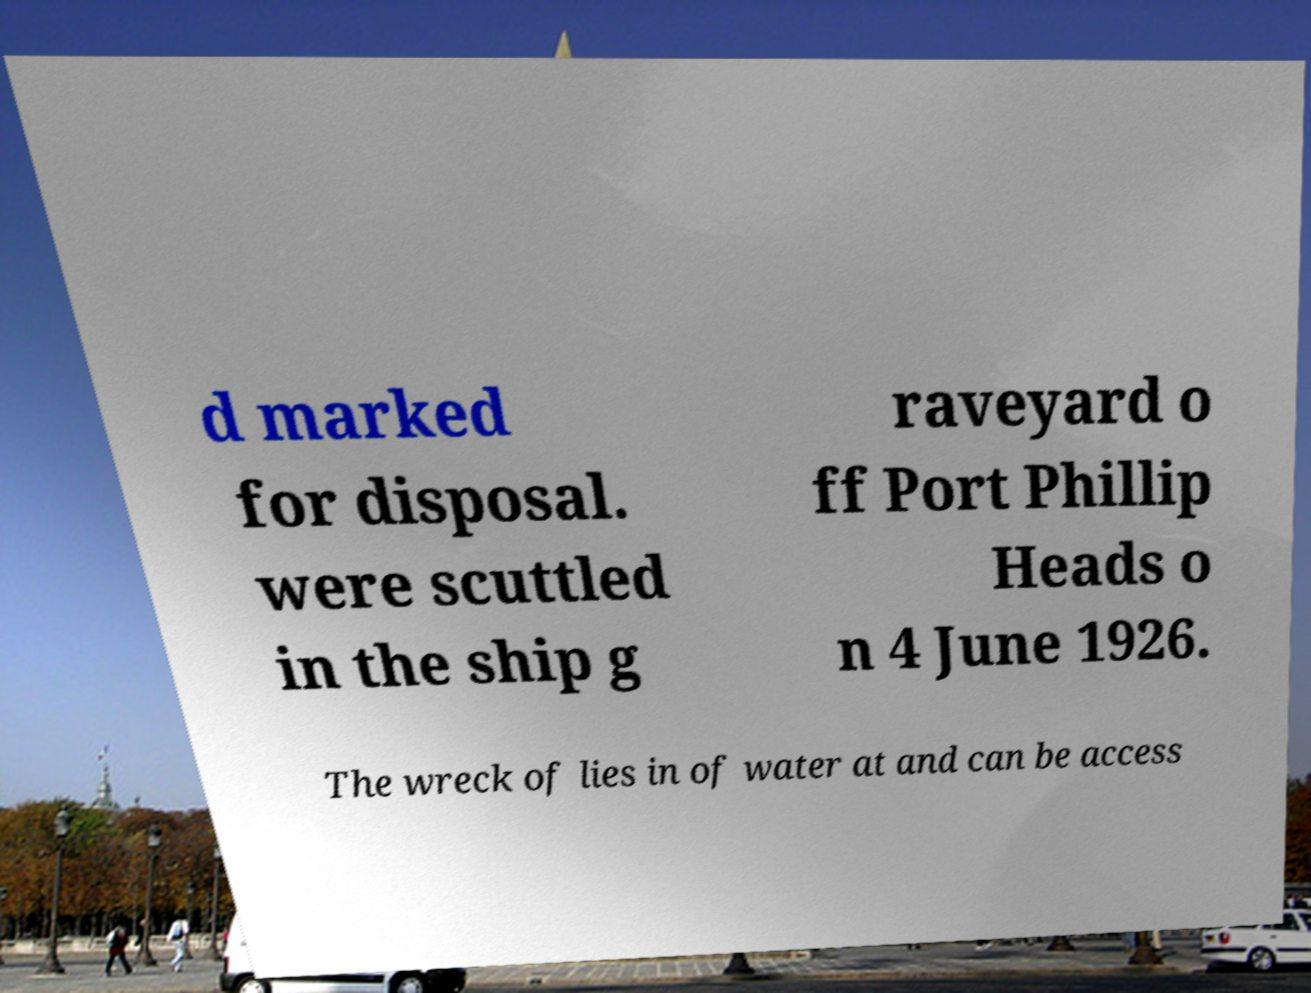For documentation purposes, I need the text within this image transcribed. Could you provide that? d marked for disposal. were scuttled in the ship g raveyard o ff Port Phillip Heads o n 4 June 1926. The wreck of lies in of water at and can be access 